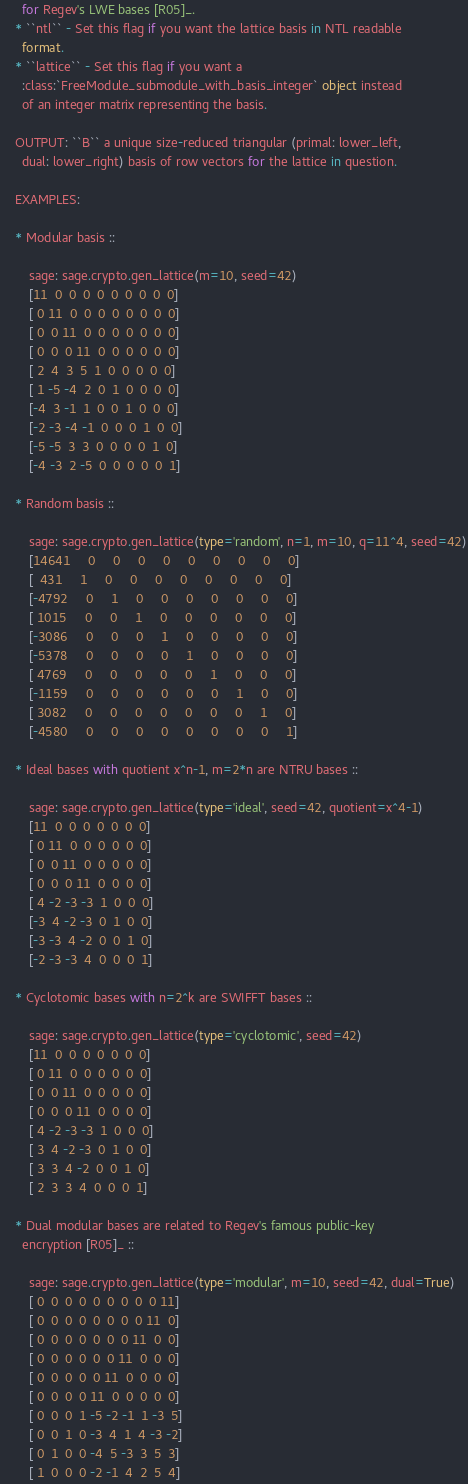Convert code to text. <code><loc_0><loc_0><loc_500><loc_500><_Python_>      for Regev's LWE bases [R05]_.
    * ``ntl`` - Set this flag if you want the lattice basis in NTL readable
      format.
    * ``lattice`` - Set this flag if you want a
      :class:`FreeModule_submodule_with_basis_integer` object instead
      of an integer matrix representing the basis.

    OUTPUT: ``B`` a unique size-reduced triangular (primal: lower_left,
      dual: lower_right) basis of row vectors for the lattice in question.

    EXAMPLES:

    * Modular basis ::

        sage: sage.crypto.gen_lattice(m=10, seed=42)
        [11  0  0  0  0  0  0  0  0  0]
        [ 0 11  0  0  0  0  0  0  0  0]
        [ 0  0 11  0  0  0  0  0  0  0]
        [ 0  0  0 11  0  0  0  0  0  0]
        [ 2  4  3  5  1  0  0  0  0  0]
        [ 1 -5 -4  2  0  1  0  0  0  0]
        [-4  3 -1  1  0  0  1  0  0  0]
        [-2 -3 -4 -1  0  0  0  1  0  0]
        [-5 -5  3  3  0  0  0  0  1  0]
        [-4 -3  2 -5  0  0  0  0  0  1]

    * Random basis ::

        sage: sage.crypto.gen_lattice(type='random', n=1, m=10, q=11^4, seed=42)
        [14641     0     0     0     0     0     0     0     0     0]
        [  431     1     0     0     0     0     0     0     0     0]
        [-4792     0     1     0     0     0     0     0     0     0]
        [ 1015     0     0     1     0     0     0     0     0     0]
        [-3086     0     0     0     1     0     0     0     0     0]
        [-5378     0     0     0     0     1     0     0     0     0]
        [ 4769     0     0     0     0     0     1     0     0     0]
        [-1159     0     0     0     0     0     0     1     0     0]
        [ 3082     0     0     0     0     0     0     0     1     0]
        [-4580     0     0     0     0     0     0     0     0     1]

    * Ideal bases with quotient x^n-1, m=2*n are NTRU bases ::

        sage: sage.crypto.gen_lattice(type='ideal', seed=42, quotient=x^4-1)
        [11  0  0  0  0  0  0  0]
        [ 0 11  0  0  0  0  0  0]
        [ 0  0 11  0  0  0  0  0]
        [ 0  0  0 11  0  0  0  0]
        [ 4 -2 -3 -3  1  0  0  0]
        [-3  4 -2 -3  0  1  0  0]
        [-3 -3  4 -2  0  0  1  0]
        [-2 -3 -3  4  0  0  0  1]

    * Cyclotomic bases with n=2^k are SWIFFT bases ::

        sage: sage.crypto.gen_lattice(type='cyclotomic', seed=42)
        [11  0  0  0  0  0  0  0]
        [ 0 11  0  0  0  0  0  0]
        [ 0  0 11  0  0  0  0  0]
        [ 0  0  0 11  0  0  0  0]
        [ 4 -2 -3 -3  1  0  0  0]
        [ 3  4 -2 -3  0  1  0  0]
        [ 3  3  4 -2  0  0  1  0]
        [ 2  3  3  4  0  0  0  1]

    * Dual modular bases are related to Regev's famous public-key
      encryption [R05]_ ::

        sage: sage.crypto.gen_lattice(type='modular', m=10, seed=42, dual=True)
        [ 0  0  0  0  0  0  0  0  0 11]
        [ 0  0  0  0  0  0  0  0 11  0]
        [ 0  0  0  0  0  0  0 11  0  0]
        [ 0  0  0  0  0  0 11  0  0  0]
        [ 0  0  0  0  0 11  0  0  0  0]
        [ 0  0  0  0 11  0  0  0  0  0]
        [ 0  0  0  1 -5 -2 -1  1 -3  5]
        [ 0  0  1  0 -3  4  1  4 -3 -2]
        [ 0  1  0  0 -4  5 -3  3  5  3]
        [ 1  0  0  0 -2 -1  4  2  5  4]
</code> 